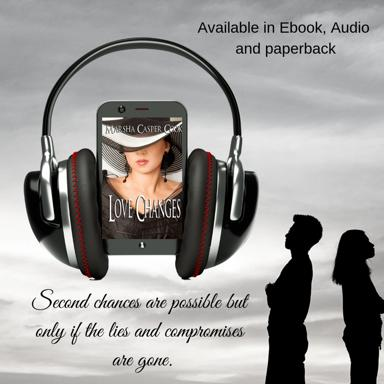Can you describe the mood or tone the image evokes regarding second chances? The image, with its overcast sky and silhouetted figures gazing into the distance, paints a reflective and somber mood, suggesting that the prospect of second chances comes with a contemplative and serious acknowledgment of past mistakes. 